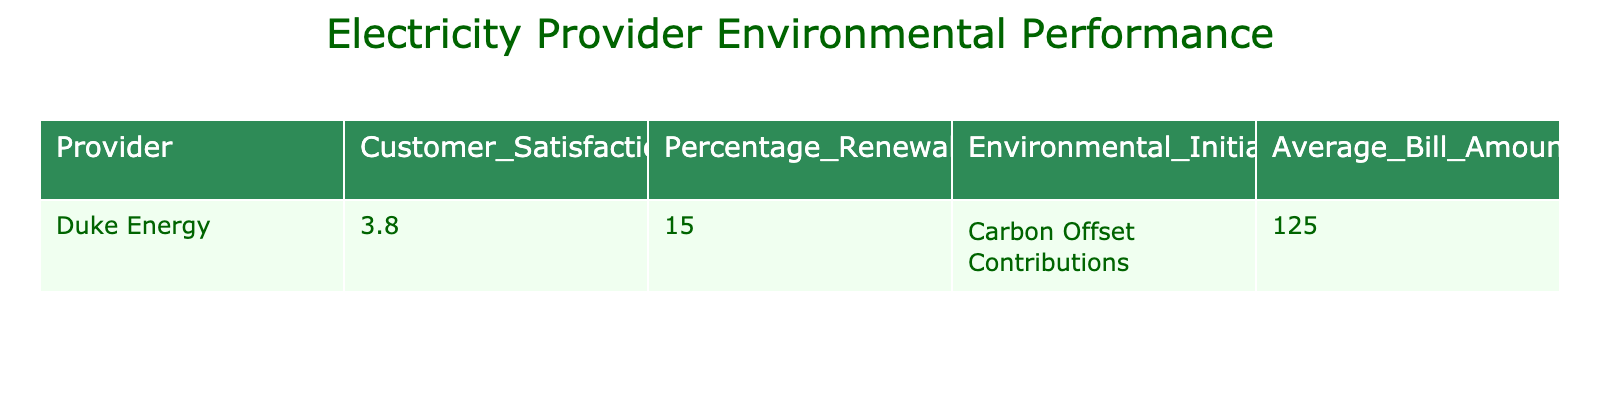What is the Customer Satisfaction Rating for Duke Energy? The table lists Duke Energy's Customer Satisfaction Rating as 3.8.
Answer: 3.8 What percentage of renewable energy does Duke Energy utilize? According to the table, Duke Energy uses 15% renewable energy.
Answer: 15% Does Duke Energy have any Environmental Initiatives? The table indicates that Duke Energy participates in "Carbon Offset Contributions," which qualifies as an Environmental Initiative.
Answer: Yes What is the Average Bill Amount for Duke Energy? The Average Bill Amount for Duke Energy is stated as $125 in the table.
Answer: $125 If we consider the Customer Satisfaction Rating and the Percentage of Renewable Energy, which aspect is higher for Duke Energy? Duke Energy’s Customer Satisfaction Rating (3.8) is higher than its Percentage of Renewable Energy (15%). Here, it is necessary to compare the two values side-by-side to draw a conclusion about which one is higher.
Answer: Customer Satisfaction Rating What is the average percentage of renewable energy if we only considered Duke Energy? Since there is only one provider, the average percentage equals the Percentage of Renewable Energy of Duke Energy, which is 15%.
Answer: 15% Is the Average Bill Amount higher than $100 for Duke Energy? The Average Bill Amount listed for Duke Energy is $125, which is indeed higher than $100.
Answer: Yes What is the difference between Duke Energy's Customer Satisfaction Rating and Average Bill Amount? Duke Energy has a Customer Satisfaction Rating of 3.8 and an Average Bill Amount of $125, so the difference is $125 - 3.8 = $121.2. However, as these values are not directly comparable (one is a rating and the other is a monetary amount), it is more appropriate to say the figures are not directly related.
Answer: Not directly comparable What would be the average bill amount if all providers had the same rating as Duke Energy? In this case, since there's only one provider listed (Duke Energy), the average bill amount remains the same as Duke Energy's, which is $125.
Answer: $125 If Duke Energy increased its percentage of renewable energy to 20%, what would be the new percentage increase? The current percentage is 15%, and increasing it to 20% means the increase is 20 - 15 = 5. Therefore, the percentage increase would be (5/15) * 100% = 33.33%.
Answer: 33.33% 